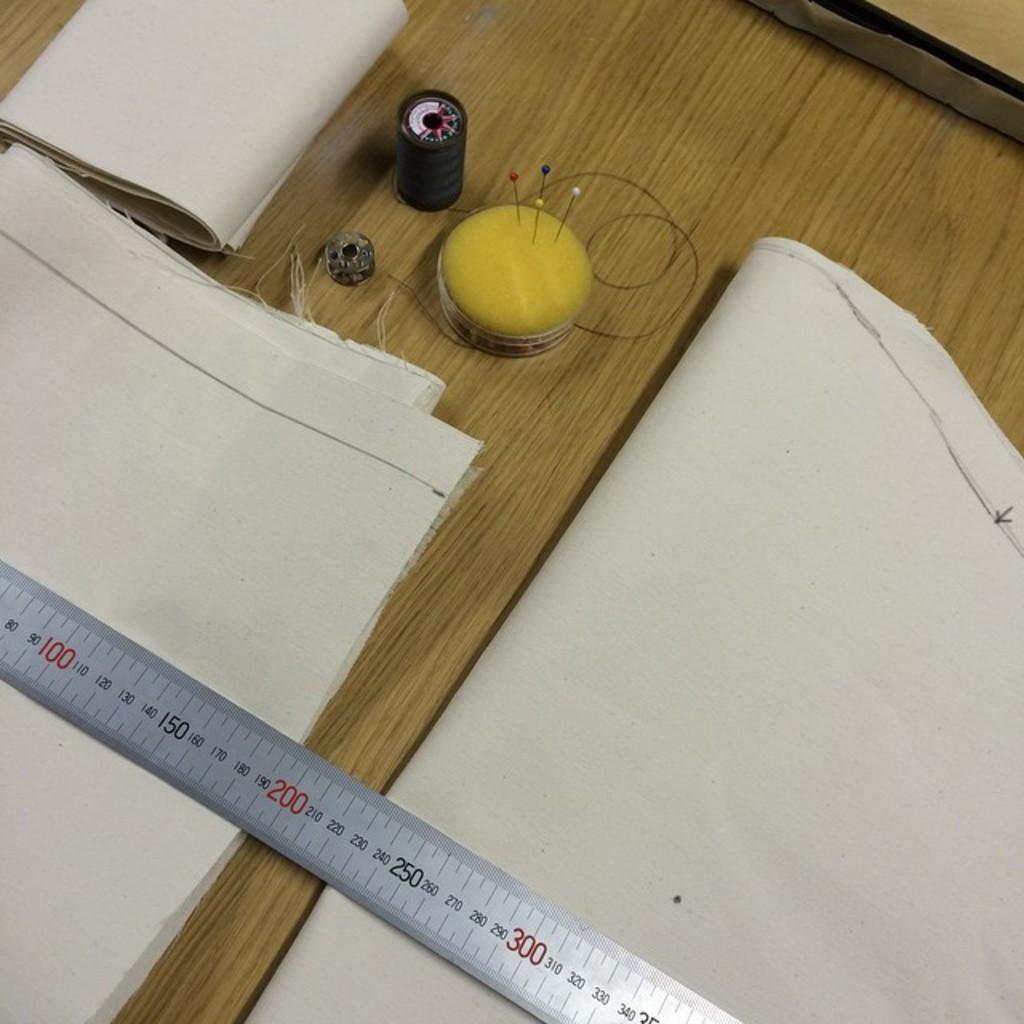<image>
Share a concise interpretation of the image provided. The ruler on the desk measures at least to 350. 